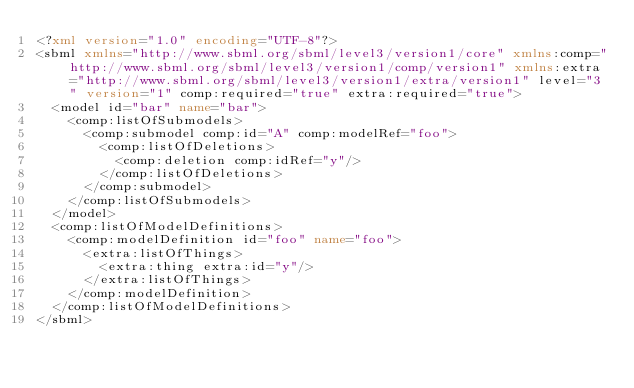Convert code to text. <code><loc_0><loc_0><loc_500><loc_500><_XML_><?xml version="1.0" encoding="UTF-8"?>
<sbml xmlns="http://www.sbml.org/sbml/level3/version1/core" xmlns:comp="http://www.sbml.org/sbml/level3/version1/comp/version1" xmlns:extra="http://www.sbml.org/sbml/level3/version1/extra/version1" level="3" version="1" comp:required="true" extra:required="true">
  <model id="bar" name="bar">
    <comp:listOfSubmodels>
      <comp:submodel comp:id="A" comp:modelRef="foo">
        <comp:listOfDeletions>
          <comp:deletion comp:idRef="y"/>
        </comp:listOfDeletions>
      </comp:submodel>
    </comp:listOfSubmodels>
  </model>
  <comp:listOfModelDefinitions>
    <comp:modelDefinition id="foo" name="foo">
      <extra:listOfThings>
        <extra:thing extra:id="y"/>
      </extra:listOfThings>
    </comp:modelDefinition>
  </comp:listOfModelDefinitions>
</sbml>
</code> 